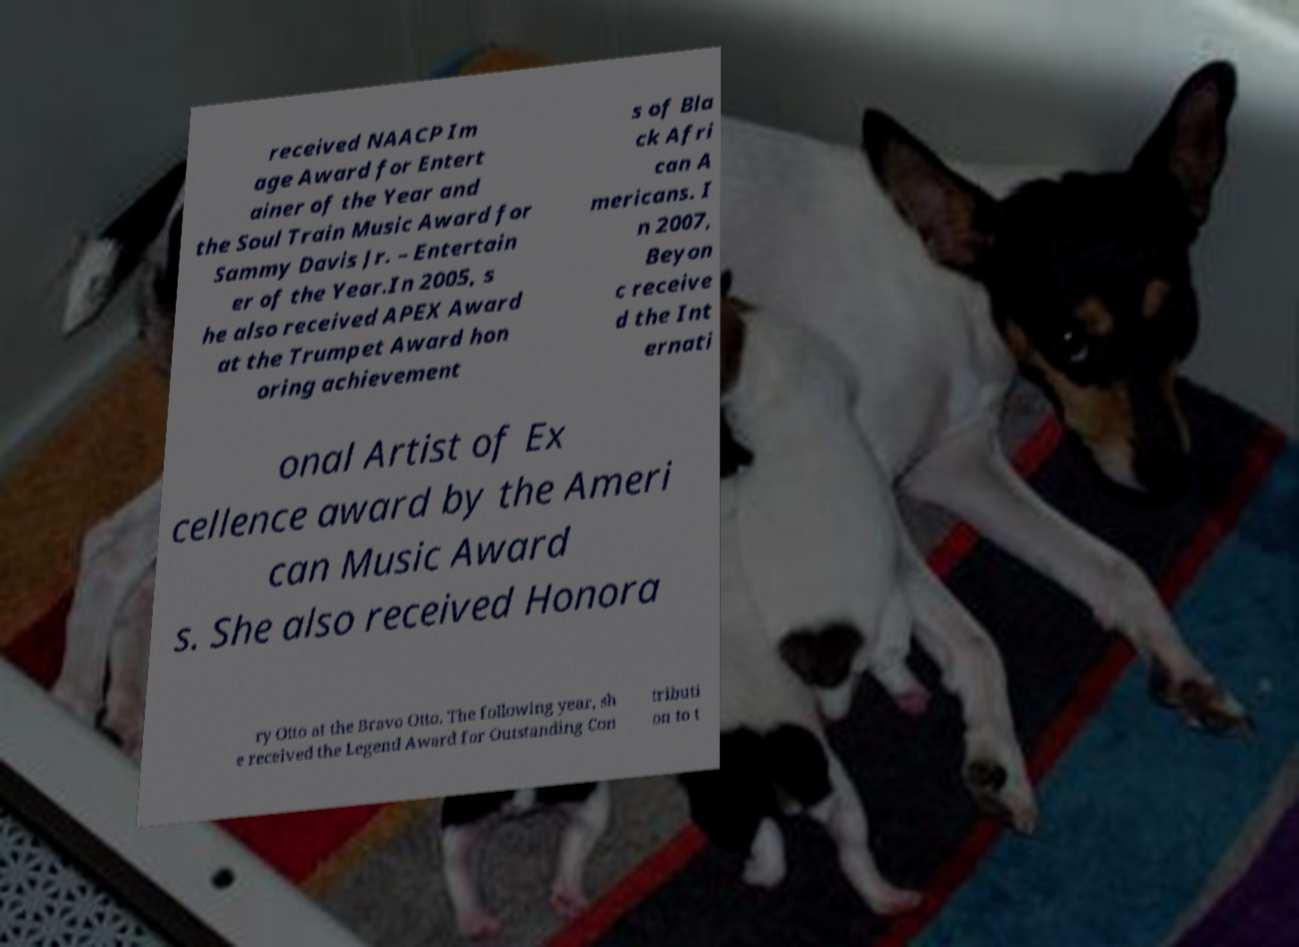Please identify and transcribe the text found in this image. received NAACP Im age Award for Entert ainer of the Year and the Soul Train Music Award for Sammy Davis Jr. – Entertain er of the Year.In 2005, s he also received APEX Award at the Trumpet Award hon oring achievement s of Bla ck Afri can A mericans. I n 2007, Beyon c receive d the Int ernati onal Artist of Ex cellence award by the Ameri can Music Award s. She also received Honora ry Otto at the Bravo Otto. The following year, sh e received the Legend Award for Outstanding Con tributi on to t 